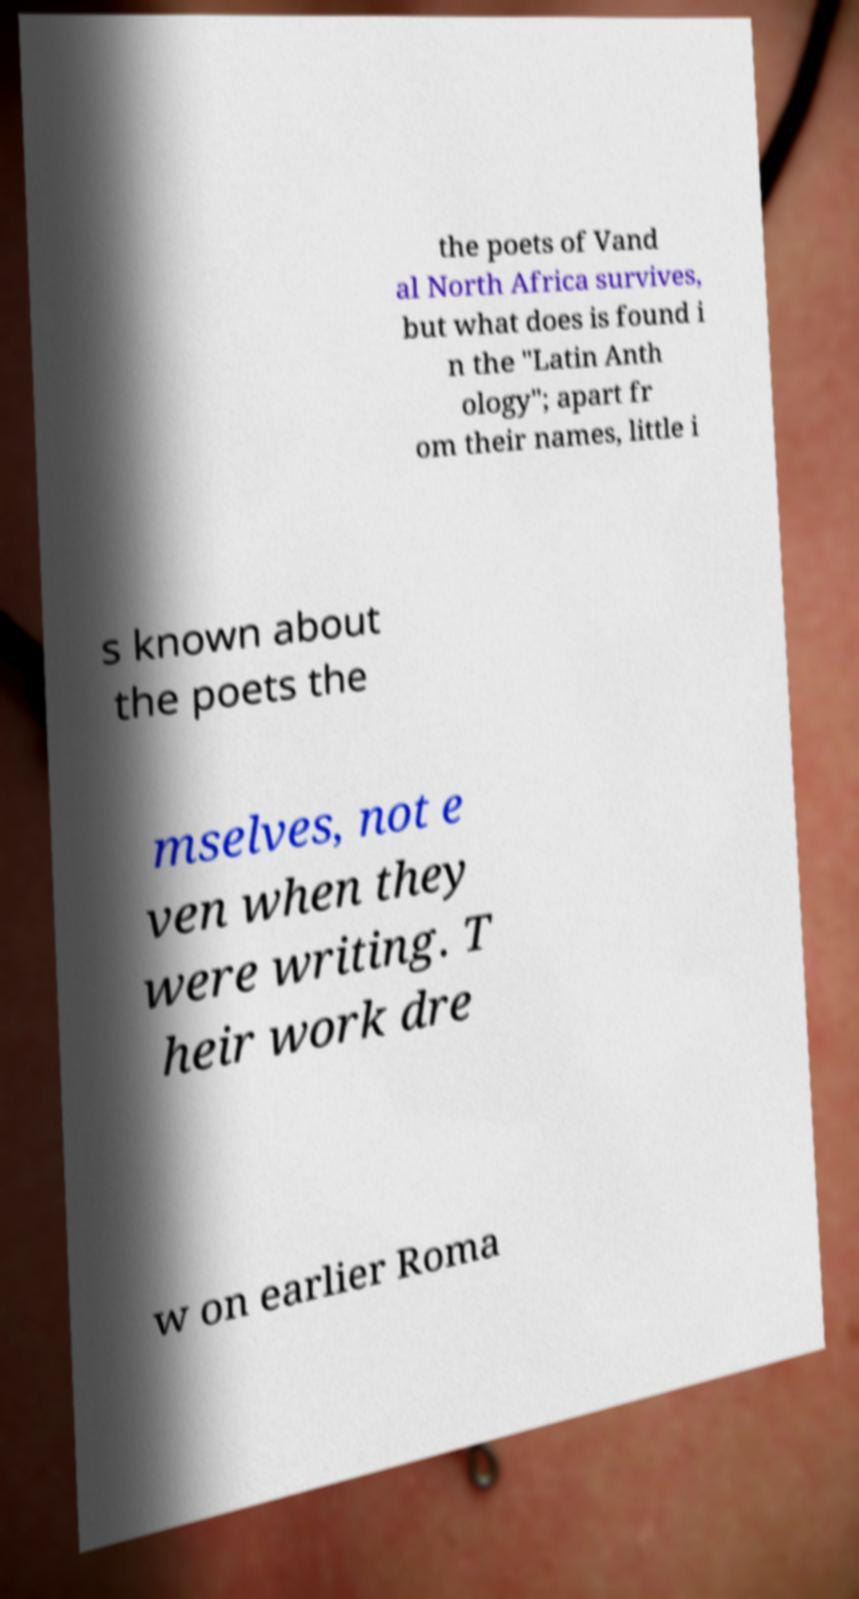Can you read and provide the text displayed in the image?This photo seems to have some interesting text. Can you extract and type it out for me? the poets of Vand al North Africa survives, but what does is found i n the "Latin Anth ology"; apart fr om their names, little i s known about the poets the mselves, not e ven when they were writing. T heir work dre w on earlier Roma 